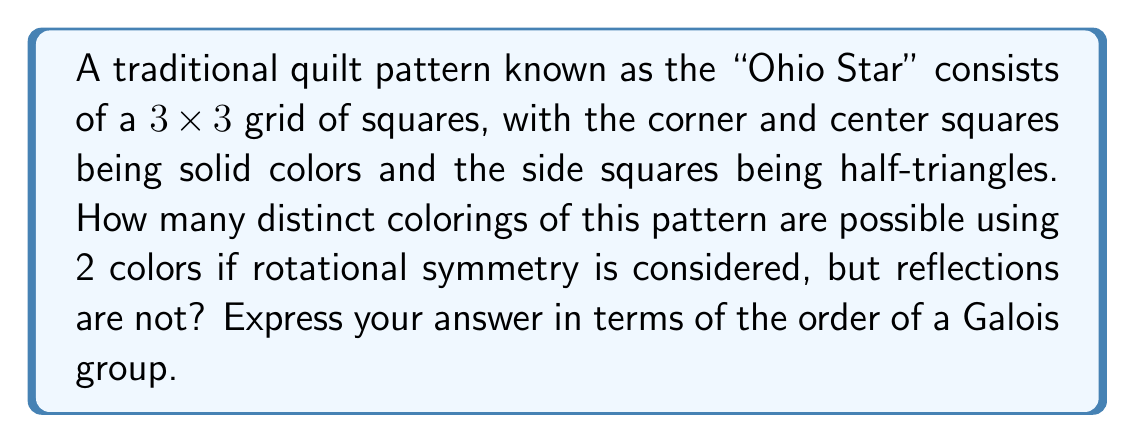Can you answer this question? Let's approach this step-by-step using Galois theory:

1) First, we need to identify the symmetry group of the Ohio Star pattern. Without reflections, we have rotational symmetry of order 4 (0°, 90°, 180°, 270°).

2) We can represent each coloring as a polynomial over the field $\mathbb{F}_2$ (since we're using 2 colors). Let's assign variables to each square:

   $$\begin{bmatrix}
   a & b & c \\
   d & e & f \\
   g & h & i
   \end{bmatrix}$$

3) The rotational symmetry implies that $(a,c,i,g)$, $(b,f,h,d)$, and $e$ form orbits under the action of the symmetry group.

4) This means our polynomial will be of the form:

   $$P(x) = (x-a)(x-c)(x-i)(x-g)(x-b)(x-f)(x-h)(x-d)(x-e)$$

5) The coefficients of this polynomial are invariant under the action of the symmetry group, so they generate a subfield of $\mathbb{F}_2(a,b,c,d,e,f,g,h,i)$.

6) The Galois group of this extension is isomorphic to our symmetry group, which is cyclic of order 4.

7) By the fundamental theorem of Galois theory, the number of distinct colorings is equal to the order of this Galois group.

Therefore, the number of distinct colorings is equal to the order of a cyclic Galois group of order 4.
Answer: 4 